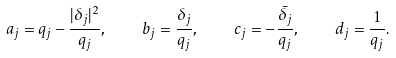Convert formula to latex. <formula><loc_0><loc_0><loc_500><loc_500>a _ { j } = q _ { j } - \frac { | \delta _ { j } | ^ { 2 } } { q _ { j } } , \quad b _ { j } = \frac { \delta _ { j } } { q _ { j } } , \quad c _ { j } = - \frac { \bar { \delta _ { j } } } { q _ { j } } , \quad d _ { j } = \frac { 1 } { q _ { j } } .</formula> 